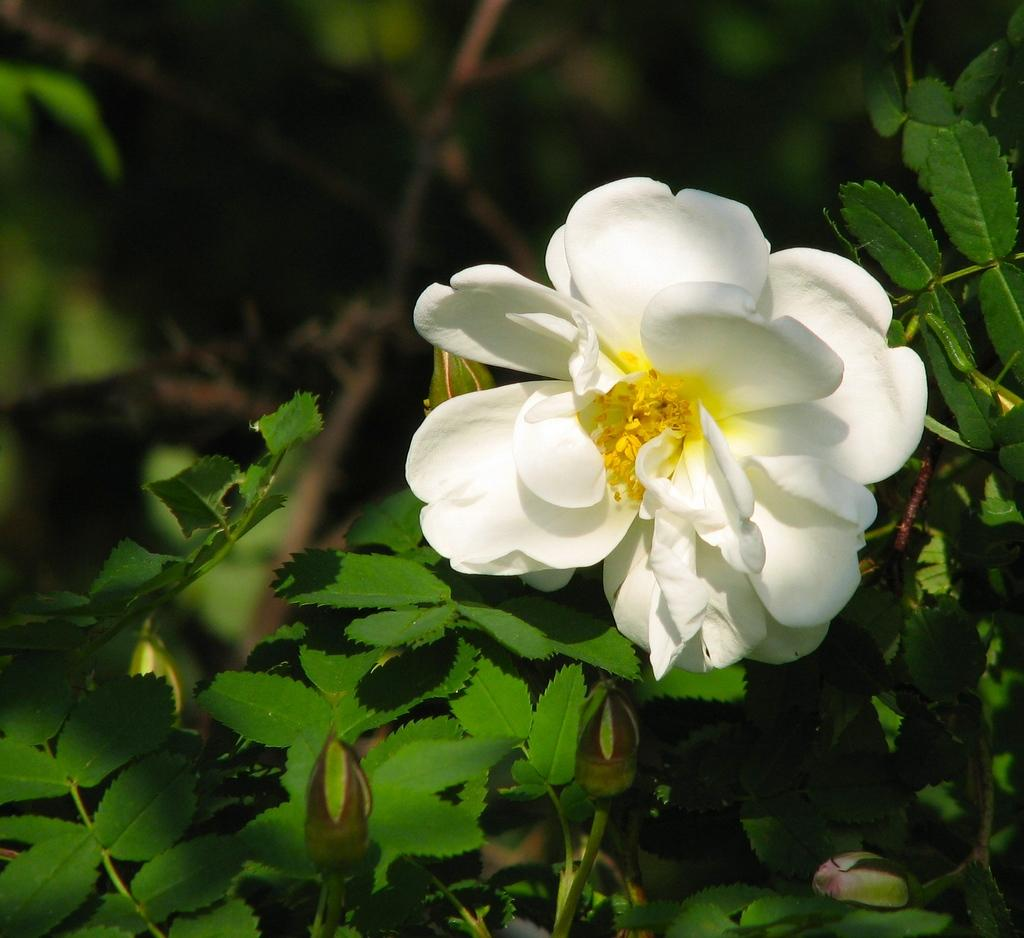What type of plant can be seen in the image? There is a flower in the image. Are there any other plants visible in the image? Yes, there are plants in the image. Can you describe the background of the image? The background of the image is blurry. What type of mine can be seen in the background of the image? There is no mine present in the image; the background is blurry and does not show any specific structures or objects. 